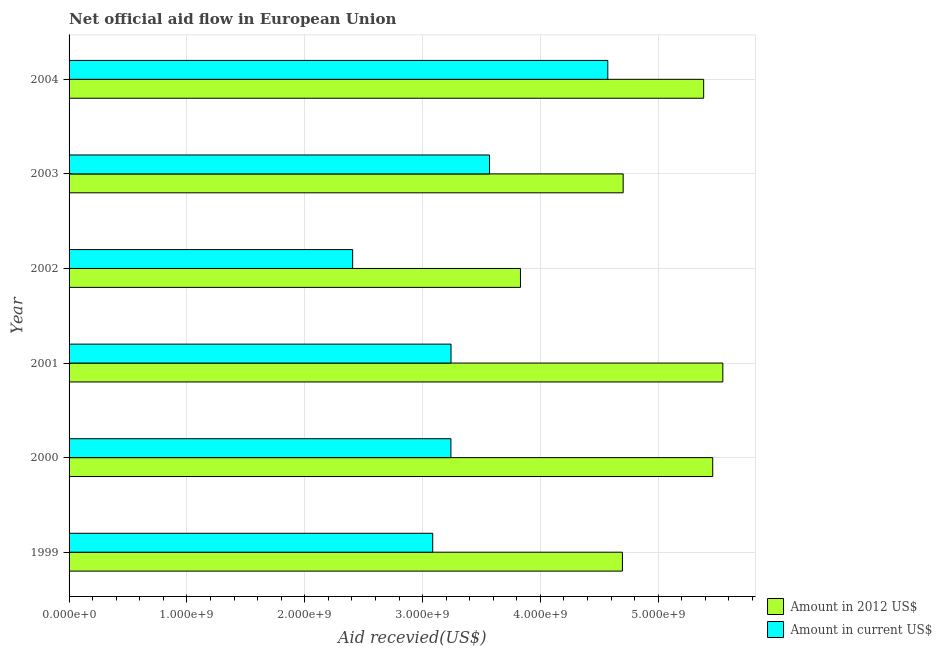Are the number of bars on each tick of the Y-axis equal?
Offer a very short reply. Yes. In how many cases, is the number of bars for a given year not equal to the number of legend labels?
Give a very brief answer. 0. What is the amount of aid received(expressed in 2012 us$) in 2004?
Provide a short and direct response. 5.39e+09. Across all years, what is the maximum amount of aid received(expressed in 2012 us$)?
Your answer should be compact. 5.55e+09. Across all years, what is the minimum amount of aid received(expressed in 2012 us$)?
Keep it short and to the point. 3.83e+09. What is the total amount of aid received(expressed in 2012 us$) in the graph?
Ensure brevity in your answer.  2.96e+1. What is the difference between the amount of aid received(expressed in us$) in 2000 and that in 2002?
Your response must be concise. 8.34e+08. What is the difference between the amount of aid received(expressed in us$) in 2003 and the amount of aid received(expressed in 2012 us$) in 2002?
Your response must be concise. -2.63e+08. What is the average amount of aid received(expressed in us$) per year?
Make the answer very short. 3.35e+09. In the year 2000, what is the difference between the amount of aid received(expressed in 2012 us$) and amount of aid received(expressed in us$)?
Offer a very short reply. 2.22e+09. What is the ratio of the amount of aid received(expressed in us$) in 1999 to that in 2004?
Offer a very short reply. 0.68. Is the amount of aid received(expressed in us$) in 2000 less than that in 2004?
Your answer should be very brief. Yes. What is the difference between the highest and the second highest amount of aid received(expressed in us$)?
Offer a very short reply. 1.00e+09. What is the difference between the highest and the lowest amount of aid received(expressed in 2012 us$)?
Make the answer very short. 1.72e+09. In how many years, is the amount of aid received(expressed in us$) greater than the average amount of aid received(expressed in us$) taken over all years?
Your answer should be very brief. 2. Is the sum of the amount of aid received(expressed in us$) in 2000 and 2003 greater than the maximum amount of aid received(expressed in 2012 us$) across all years?
Offer a terse response. Yes. What does the 2nd bar from the top in 2004 represents?
Give a very brief answer. Amount in 2012 US$. What does the 2nd bar from the bottom in 2002 represents?
Provide a short and direct response. Amount in current US$. Does the graph contain any zero values?
Your response must be concise. No. How many legend labels are there?
Provide a short and direct response. 2. How are the legend labels stacked?
Offer a very short reply. Vertical. What is the title of the graph?
Provide a succinct answer. Net official aid flow in European Union. Does "Girls" appear as one of the legend labels in the graph?
Give a very brief answer. No. What is the label or title of the X-axis?
Offer a terse response. Aid recevied(US$). What is the Aid recevied(US$) of Amount in 2012 US$ in 1999?
Provide a succinct answer. 4.70e+09. What is the Aid recevied(US$) of Amount in current US$ in 1999?
Your response must be concise. 3.09e+09. What is the Aid recevied(US$) of Amount in 2012 US$ in 2000?
Your answer should be very brief. 5.46e+09. What is the Aid recevied(US$) in Amount in current US$ in 2000?
Provide a succinct answer. 3.24e+09. What is the Aid recevied(US$) in Amount in 2012 US$ in 2001?
Ensure brevity in your answer.  5.55e+09. What is the Aid recevied(US$) in Amount in current US$ in 2001?
Offer a terse response. 3.24e+09. What is the Aid recevied(US$) of Amount in 2012 US$ in 2002?
Your response must be concise. 3.83e+09. What is the Aid recevied(US$) of Amount in current US$ in 2002?
Your response must be concise. 2.41e+09. What is the Aid recevied(US$) of Amount in 2012 US$ in 2003?
Ensure brevity in your answer.  4.70e+09. What is the Aid recevied(US$) of Amount in current US$ in 2003?
Make the answer very short. 3.57e+09. What is the Aid recevied(US$) in Amount in 2012 US$ in 2004?
Your answer should be very brief. 5.39e+09. What is the Aid recevied(US$) of Amount in current US$ in 2004?
Provide a short and direct response. 4.57e+09. Across all years, what is the maximum Aid recevied(US$) in Amount in 2012 US$?
Make the answer very short. 5.55e+09. Across all years, what is the maximum Aid recevied(US$) of Amount in current US$?
Your response must be concise. 4.57e+09. Across all years, what is the minimum Aid recevied(US$) in Amount in 2012 US$?
Provide a succinct answer. 3.83e+09. Across all years, what is the minimum Aid recevied(US$) of Amount in current US$?
Provide a succinct answer. 2.41e+09. What is the total Aid recevied(US$) of Amount in 2012 US$ in the graph?
Your response must be concise. 2.96e+1. What is the total Aid recevied(US$) of Amount in current US$ in the graph?
Provide a short and direct response. 2.01e+1. What is the difference between the Aid recevied(US$) in Amount in 2012 US$ in 1999 and that in 2000?
Provide a short and direct response. -7.66e+08. What is the difference between the Aid recevied(US$) of Amount in current US$ in 1999 and that in 2000?
Keep it short and to the point. -1.55e+08. What is the difference between the Aid recevied(US$) in Amount in 2012 US$ in 1999 and that in 2001?
Your answer should be compact. -8.52e+08. What is the difference between the Aid recevied(US$) in Amount in current US$ in 1999 and that in 2001?
Your answer should be very brief. -1.55e+08. What is the difference between the Aid recevied(US$) of Amount in 2012 US$ in 1999 and that in 2002?
Offer a very short reply. 8.65e+08. What is the difference between the Aid recevied(US$) of Amount in current US$ in 1999 and that in 2002?
Keep it short and to the point. 6.79e+08. What is the difference between the Aid recevied(US$) in Amount in 2012 US$ in 1999 and that in 2003?
Your response must be concise. -6.37e+06. What is the difference between the Aid recevied(US$) in Amount in current US$ in 1999 and that in 2003?
Your answer should be very brief. -4.82e+08. What is the difference between the Aid recevied(US$) in Amount in 2012 US$ in 1999 and that in 2004?
Ensure brevity in your answer.  -6.89e+08. What is the difference between the Aid recevied(US$) in Amount in current US$ in 1999 and that in 2004?
Keep it short and to the point. -1.49e+09. What is the difference between the Aid recevied(US$) in Amount in 2012 US$ in 2000 and that in 2001?
Ensure brevity in your answer.  -8.58e+07. What is the difference between the Aid recevied(US$) of Amount in current US$ in 2000 and that in 2001?
Offer a terse response. -7.70e+05. What is the difference between the Aid recevied(US$) in Amount in 2012 US$ in 2000 and that in 2002?
Provide a short and direct response. 1.63e+09. What is the difference between the Aid recevied(US$) in Amount in current US$ in 2000 and that in 2002?
Your answer should be compact. 8.34e+08. What is the difference between the Aid recevied(US$) of Amount in 2012 US$ in 2000 and that in 2003?
Make the answer very short. 7.60e+08. What is the difference between the Aid recevied(US$) in Amount in current US$ in 2000 and that in 2003?
Offer a very short reply. -3.28e+08. What is the difference between the Aid recevied(US$) in Amount in 2012 US$ in 2000 and that in 2004?
Offer a very short reply. 7.69e+07. What is the difference between the Aid recevied(US$) of Amount in current US$ in 2000 and that in 2004?
Your response must be concise. -1.33e+09. What is the difference between the Aid recevied(US$) in Amount in 2012 US$ in 2001 and that in 2002?
Your answer should be very brief. 1.72e+09. What is the difference between the Aid recevied(US$) in Amount in current US$ in 2001 and that in 2002?
Your response must be concise. 8.35e+08. What is the difference between the Aid recevied(US$) of Amount in 2012 US$ in 2001 and that in 2003?
Ensure brevity in your answer.  8.46e+08. What is the difference between the Aid recevied(US$) in Amount in current US$ in 2001 and that in 2003?
Your answer should be very brief. -3.27e+08. What is the difference between the Aid recevied(US$) of Amount in 2012 US$ in 2001 and that in 2004?
Ensure brevity in your answer.  1.63e+08. What is the difference between the Aid recevied(US$) of Amount in current US$ in 2001 and that in 2004?
Offer a terse response. -1.33e+09. What is the difference between the Aid recevied(US$) of Amount in 2012 US$ in 2002 and that in 2003?
Provide a succinct answer. -8.71e+08. What is the difference between the Aid recevied(US$) in Amount in current US$ in 2002 and that in 2003?
Offer a terse response. -1.16e+09. What is the difference between the Aid recevied(US$) of Amount in 2012 US$ in 2002 and that in 2004?
Your answer should be very brief. -1.55e+09. What is the difference between the Aid recevied(US$) of Amount in current US$ in 2002 and that in 2004?
Keep it short and to the point. -2.17e+09. What is the difference between the Aid recevied(US$) of Amount in 2012 US$ in 2003 and that in 2004?
Keep it short and to the point. -6.83e+08. What is the difference between the Aid recevied(US$) of Amount in current US$ in 2003 and that in 2004?
Your answer should be very brief. -1.00e+09. What is the difference between the Aid recevied(US$) of Amount in 2012 US$ in 1999 and the Aid recevied(US$) of Amount in current US$ in 2000?
Your answer should be very brief. 1.46e+09. What is the difference between the Aid recevied(US$) in Amount in 2012 US$ in 1999 and the Aid recevied(US$) in Amount in current US$ in 2001?
Ensure brevity in your answer.  1.45e+09. What is the difference between the Aid recevied(US$) in Amount in 2012 US$ in 1999 and the Aid recevied(US$) in Amount in current US$ in 2002?
Your answer should be compact. 2.29e+09. What is the difference between the Aid recevied(US$) in Amount in 2012 US$ in 1999 and the Aid recevied(US$) in Amount in current US$ in 2003?
Provide a succinct answer. 1.13e+09. What is the difference between the Aid recevied(US$) of Amount in 2012 US$ in 1999 and the Aid recevied(US$) of Amount in current US$ in 2004?
Make the answer very short. 1.24e+08. What is the difference between the Aid recevied(US$) in Amount in 2012 US$ in 2000 and the Aid recevied(US$) in Amount in current US$ in 2001?
Offer a terse response. 2.22e+09. What is the difference between the Aid recevied(US$) of Amount in 2012 US$ in 2000 and the Aid recevied(US$) of Amount in current US$ in 2002?
Provide a short and direct response. 3.06e+09. What is the difference between the Aid recevied(US$) in Amount in 2012 US$ in 2000 and the Aid recevied(US$) in Amount in current US$ in 2003?
Provide a short and direct response. 1.89e+09. What is the difference between the Aid recevied(US$) in Amount in 2012 US$ in 2000 and the Aid recevied(US$) in Amount in current US$ in 2004?
Offer a terse response. 8.90e+08. What is the difference between the Aid recevied(US$) of Amount in 2012 US$ in 2001 and the Aid recevied(US$) of Amount in current US$ in 2002?
Make the answer very short. 3.14e+09. What is the difference between the Aid recevied(US$) of Amount in 2012 US$ in 2001 and the Aid recevied(US$) of Amount in current US$ in 2003?
Your response must be concise. 1.98e+09. What is the difference between the Aid recevied(US$) in Amount in 2012 US$ in 2001 and the Aid recevied(US$) in Amount in current US$ in 2004?
Ensure brevity in your answer.  9.76e+08. What is the difference between the Aid recevied(US$) in Amount in 2012 US$ in 2002 and the Aid recevied(US$) in Amount in current US$ in 2003?
Make the answer very short. 2.63e+08. What is the difference between the Aid recevied(US$) in Amount in 2012 US$ in 2002 and the Aid recevied(US$) in Amount in current US$ in 2004?
Make the answer very short. -7.41e+08. What is the difference between the Aid recevied(US$) of Amount in 2012 US$ in 2003 and the Aid recevied(US$) of Amount in current US$ in 2004?
Keep it short and to the point. 1.30e+08. What is the average Aid recevied(US$) in Amount in 2012 US$ per year?
Your answer should be compact. 4.94e+09. What is the average Aid recevied(US$) in Amount in current US$ per year?
Keep it short and to the point. 3.35e+09. In the year 1999, what is the difference between the Aid recevied(US$) of Amount in 2012 US$ and Aid recevied(US$) of Amount in current US$?
Ensure brevity in your answer.  1.61e+09. In the year 2000, what is the difference between the Aid recevied(US$) of Amount in 2012 US$ and Aid recevied(US$) of Amount in current US$?
Ensure brevity in your answer.  2.22e+09. In the year 2001, what is the difference between the Aid recevied(US$) of Amount in 2012 US$ and Aid recevied(US$) of Amount in current US$?
Keep it short and to the point. 2.31e+09. In the year 2002, what is the difference between the Aid recevied(US$) of Amount in 2012 US$ and Aid recevied(US$) of Amount in current US$?
Your answer should be very brief. 1.42e+09. In the year 2003, what is the difference between the Aid recevied(US$) in Amount in 2012 US$ and Aid recevied(US$) in Amount in current US$?
Give a very brief answer. 1.13e+09. In the year 2004, what is the difference between the Aid recevied(US$) of Amount in 2012 US$ and Aid recevied(US$) of Amount in current US$?
Your answer should be compact. 8.14e+08. What is the ratio of the Aid recevied(US$) of Amount in 2012 US$ in 1999 to that in 2000?
Give a very brief answer. 0.86. What is the ratio of the Aid recevied(US$) of Amount in current US$ in 1999 to that in 2000?
Ensure brevity in your answer.  0.95. What is the ratio of the Aid recevied(US$) of Amount in 2012 US$ in 1999 to that in 2001?
Your response must be concise. 0.85. What is the ratio of the Aid recevied(US$) in Amount in current US$ in 1999 to that in 2001?
Keep it short and to the point. 0.95. What is the ratio of the Aid recevied(US$) in Amount in 2012 US$ in 1999 to that in 2002?
Make the answer very short. 1.23. What is the ratio of the Aid recevied(US$) of Amount in current US$ in 1999 to that in 2002?
Offer a very short reply. 1.28. What is the ratio of the Aid recevied(US$) in Amount in 2012 US$ in 1999 to that in 2003?
Provide a succinct answer. 1. What is the ratio of the Aid recevied(US$) in Amount in current US$ in 1999 to that in 2003?
Your response must be concise. 0.86. What is the ratio of the Aid recevied(US$) in Amount in 2012 US$ in 1999 to that in 2004?
Provide a short and direct response. 0.87. What is the ratio of the Aid recevied(US$) in Amount in current US$ in 1999 to that in 2004?
Your response must be concise. 0.68. What is the ratio of the Aid recevied(US$) of Amount in 2012 US$ in 2000 to that in 2001?
Offer a very short reply. 0.98. What is the ratio of the Aid recevied(US$) in Amount in current US$ in 2000 to that in 2001?
Your answer should be very brief. 1. What is the ratio of the Aid recevied(US$) of Amount in 2012 US$ in 2000 to that in 2002?
Offer a terse response. 1.43. What is the ratio of the Aid recevied(US$) of Amount in current US$ in 2000 to that in 2002?
Provide a short and direct response. 1.35. What is the ratio of the Aid recevied(US$) of Amount in 2012 US$ in 2000 to that in 2003?
Your response must be concise. 1.16. What is the ratio of the Aid recevied(US$) in Amount in current US$ in 2000 to that in 2003?
Ensure brevity in your answer.  0.91. What is the ratio of the Aid recevied(US$) in Amount in 2012 US$ in 2000 to that in 2004?
Provide a succinct answer. 1.01. What is the ratio of the Aid recevied(US$) of Amount in current US$ in 2000 to that in 2004?
Your answer should be very brief. 0.71. What is the ratio of the Aid recevied(US$) in Amount in 2012 US$ in 2001 to that in 2002?
Make the answer very short. 1.45. What is the ratio of the Aid recevied(US$) of Amount in current US$ in 2001 to that in 2002?
Your answer should be compact. 1.35. What is the ratio of the Aid recevied(US$) of Amount in 2012 US$ in 2001 to that in 2003?
Provide a succinct answer. 1.18. What is the ratio of the Aid recevied(US$) in Amount in current US$ in 2001 to that in 2003?
Make the answer very short. 0.91. What is the ratio of the Aid recevied(US$) of Amount in 2012 US$ in 2001 to that in 2004?
Your response must be concise. 1.03. What is the ratio of the Aid recevied(US$) in Amount in current US$ in 2001 to that in 2004?
Offer a terse response. 0.71. What is the ratio of the Aid recevied(US$) in Amount in 2012 US$ in 2002 to that in 2003?
Provide a succinct answer. 0.81. What is the ratio of the Aid recevied(US$) in Amount in current US$ in 2002 to that in 2003?
Make the answer very short. 0.67. What is the ratio of the Aid recevied(US$) in Amount in 2012 US$ in 2002 to that in 2004?
Offer a terse response. 0.71. What is the ratio of the Aid recevied(US$) in Amount in current US$ in 2002 to that in 2004?
Ensure brevity in your answer.  0.53. What is the ratio of the Aid recevied(US$) in Amount in 2012 US$ in 2003 to that in 2004?
Offer a very short reply. 0.87. What is the ratio of the Aid recevied(US$) in Amount in current US$ in 2003 to that in 2004?
Your answer should be compact. 0.78. What is the difference between the highest and the second highest Aid recevied(US$) of Amount in 2012 US$?
Keep it short and to the point. 8.58e+07. What is the difference between the highest and the second highest Aid recevied(US$) of Amount in current US$?
Offer a very short reply. 1.00e+09. What is the difference between the highest and the lowest Aid recevied(US$) in Amount in 2012 US$?
Ensure brevity in your answer.  1.72e+09. What is the difference between the highest and the lowest Aid recevied(US$) of Amount in current US$?
Give a very brief answer. 2.17e+09. 